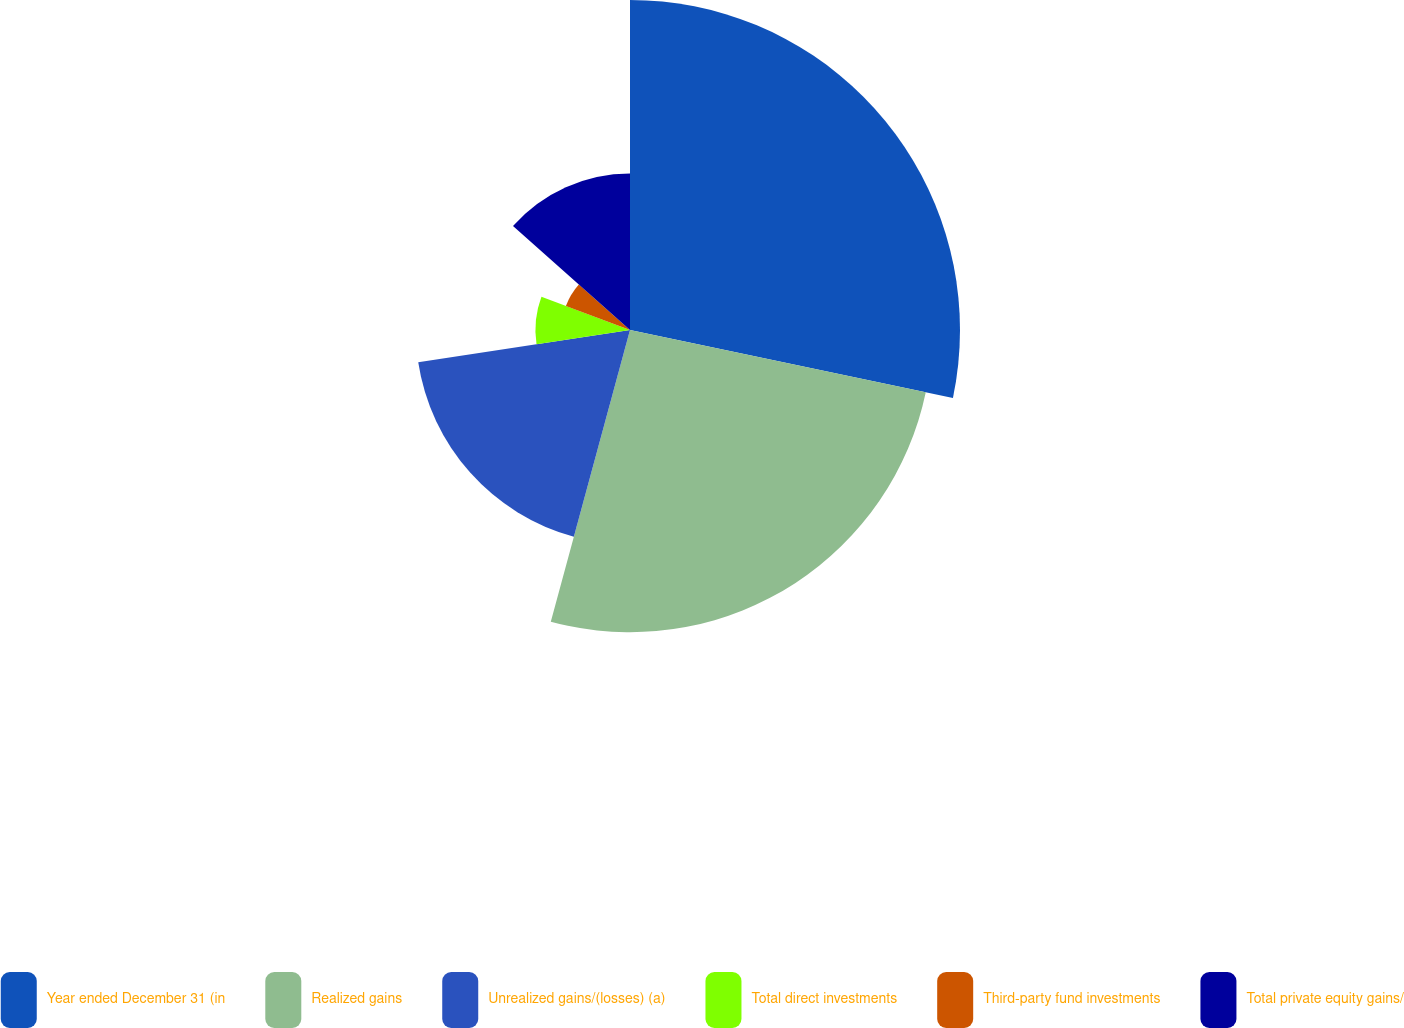<chart> <loc_0><loc_0><loc_500><loc_500><pie_chart><fcel>Year ended December 31 (in<fcel>Realized gains<fcel>Unrealized gains/(losses) (a)<fcel>Total direct investments<fcel>Third-party fund investments<fcel>Total private equity gains/<nl><fcel>28.3%<fcel>25.92%<fcel>18.37%<fcel>8.11%<fcel>5.87%<fcel>13.43%<nl></chart> 